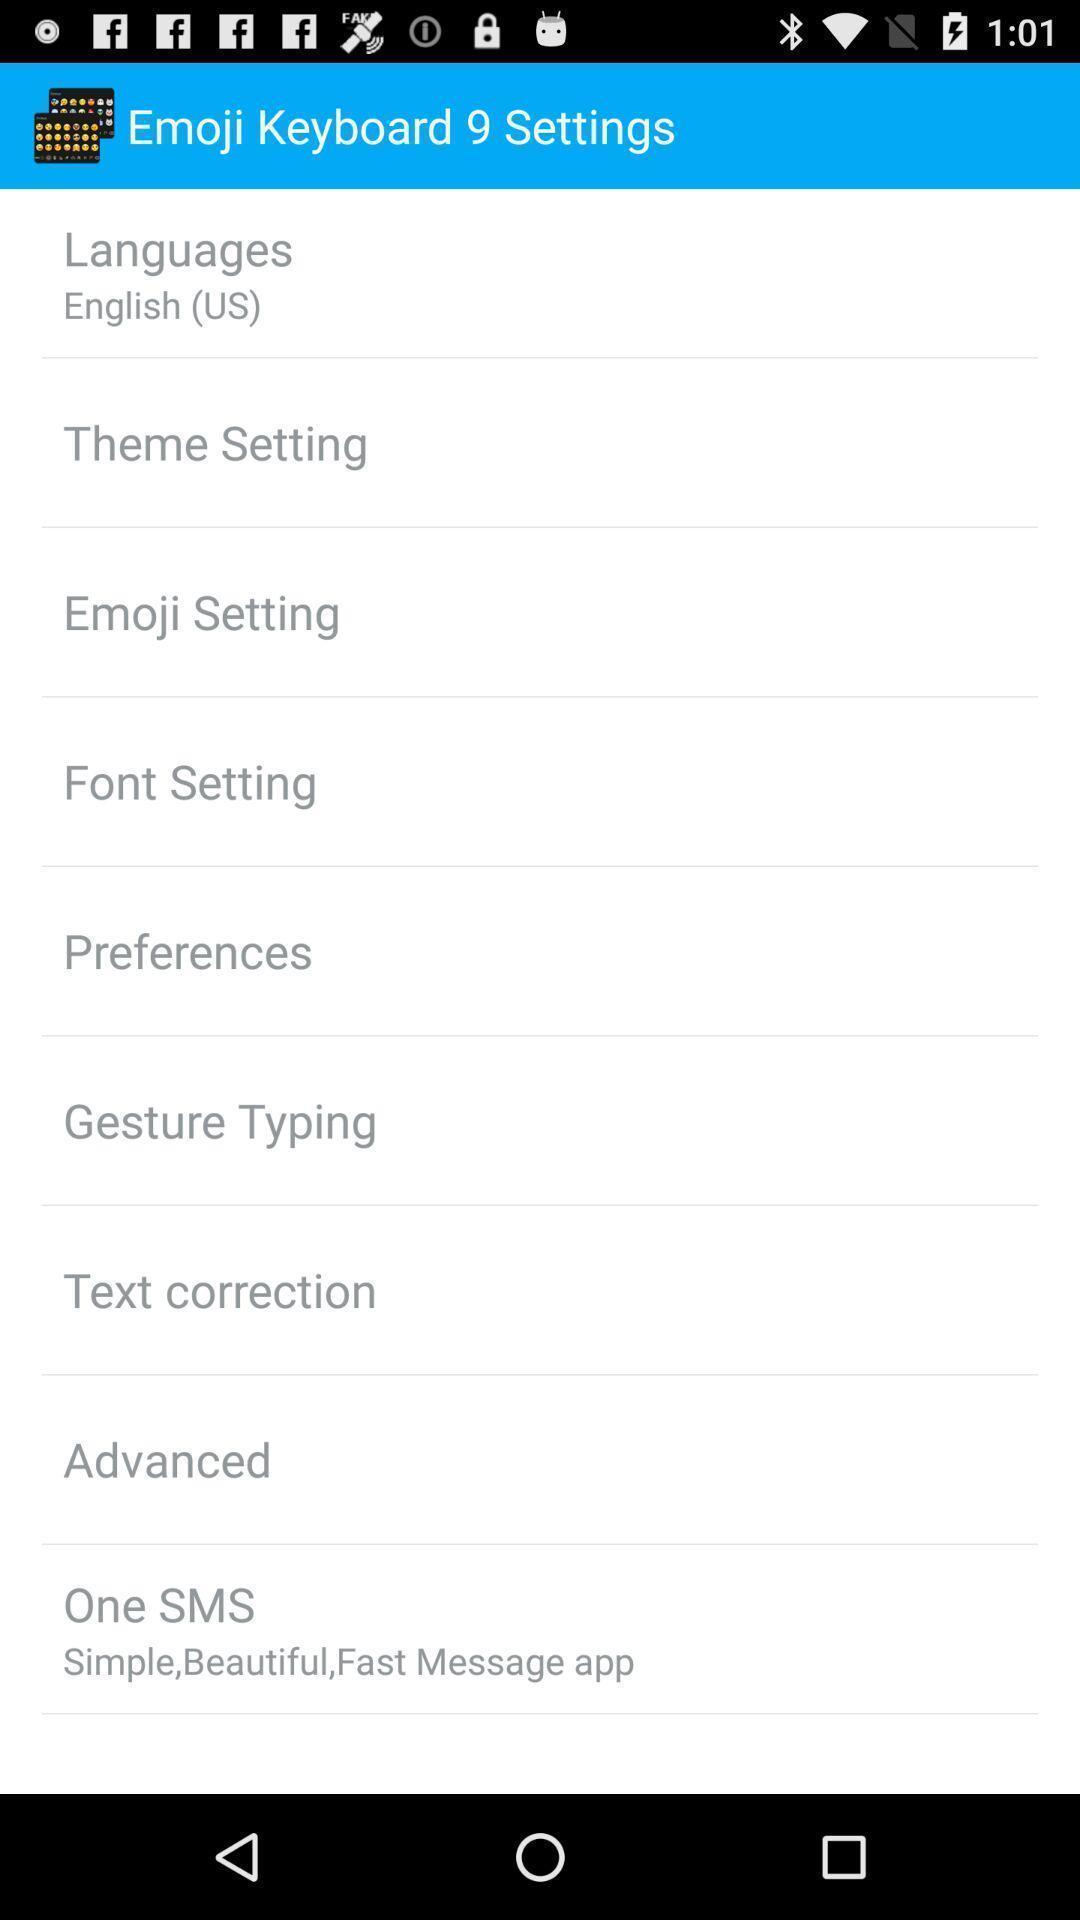Provide a description of this screenshot. Settings menu for an emoji keyboard app. 